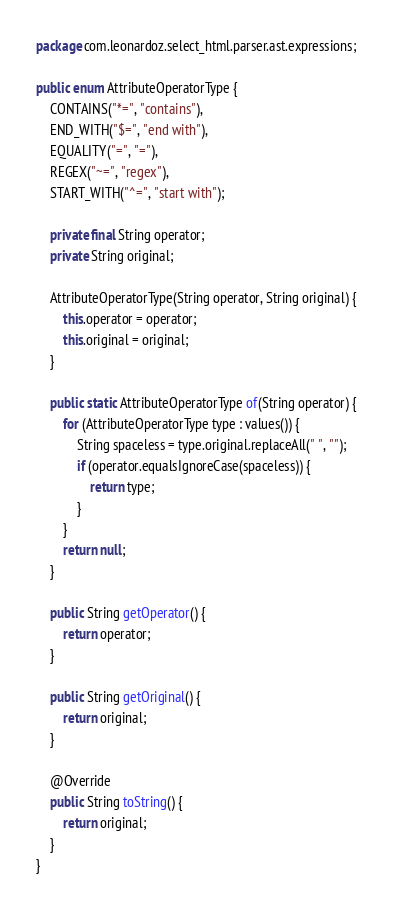<code> <loc_0><loc_0><loc_500><loc_500><_Java_>package com.leonardoz.select_html.parser.ast.expressions;

public enum AttributeOperatorType {
    CONTAINS("*=", "contains"),
    END_WITH("$=", "end with"),
    EQUALITY("=", "="),
    REGEX("~=", "regex"),
    START_WITH("^=", "start with");

    private final String operator;
    private String original;

    AttributeOperatorType(String operator, String original) {
        this.operator = operator;
        this.original = original;
    }

    public static AttributeOperatorType of(String operator) {
        for (AttributeOperatorType type : values()) {
            String spaceless = type.original.replaceAll(" ", "");
            if (operator.equalsIgnoreCase(spaceless)) {
                return type;
            }
        }
        return null;
    }

    public String getOperator() {
        return operator;
    }

    public String getOriginal() {
        return original;
    }

    @Override
    public String toString() {
        return original;
    }
}
</code> 